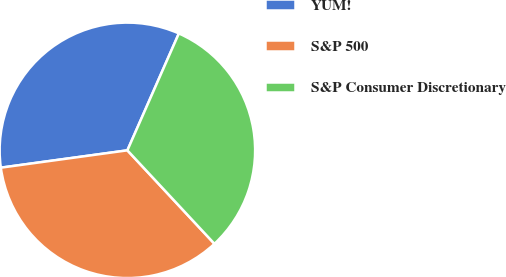<chart> <loc_0><loc_0><loc_500><loc_500><pie_chart><fcel>YUM!<fcel>S&P 500<fcel>S&P Consumer Discretionary<nl><fcel>33.77%<fcel>34.77%<fcel>31.46%<nl></chart> 